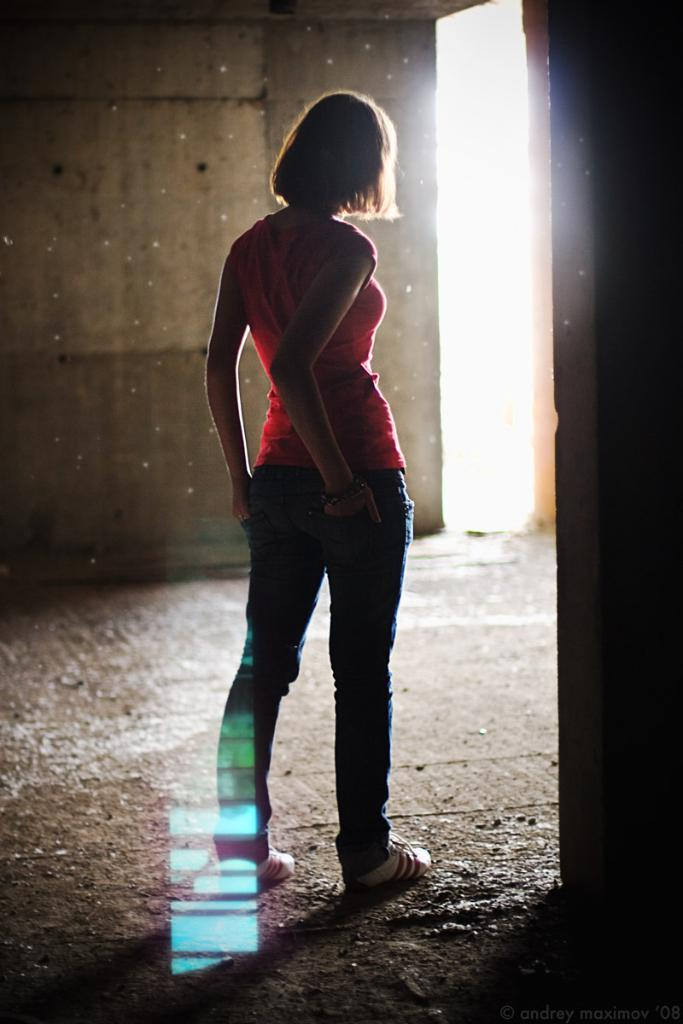Who is the main subject in the image? There is a woman in the image. Where is the woman positioned in the image? The woman is standing in the middle of the image. What type of clothing is the woman wearing on her upper body? The woman is wearing a t-shirt. What type of clothing is the woman wearing on her lower body? The woman is wearing a trouser. What type of screw can be seen in the woman's hand in the image? There is no screw present in the image; the woman is not holding anything in her hand. 